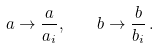Convert formula to latex. <formula><loc_0><loc_0><loc_500><loc_500>a \rightarrow \frac { a } { a _ { i } } , \quad b \rightarrow \frac { b } { b _ { i } } \, .</formula> 